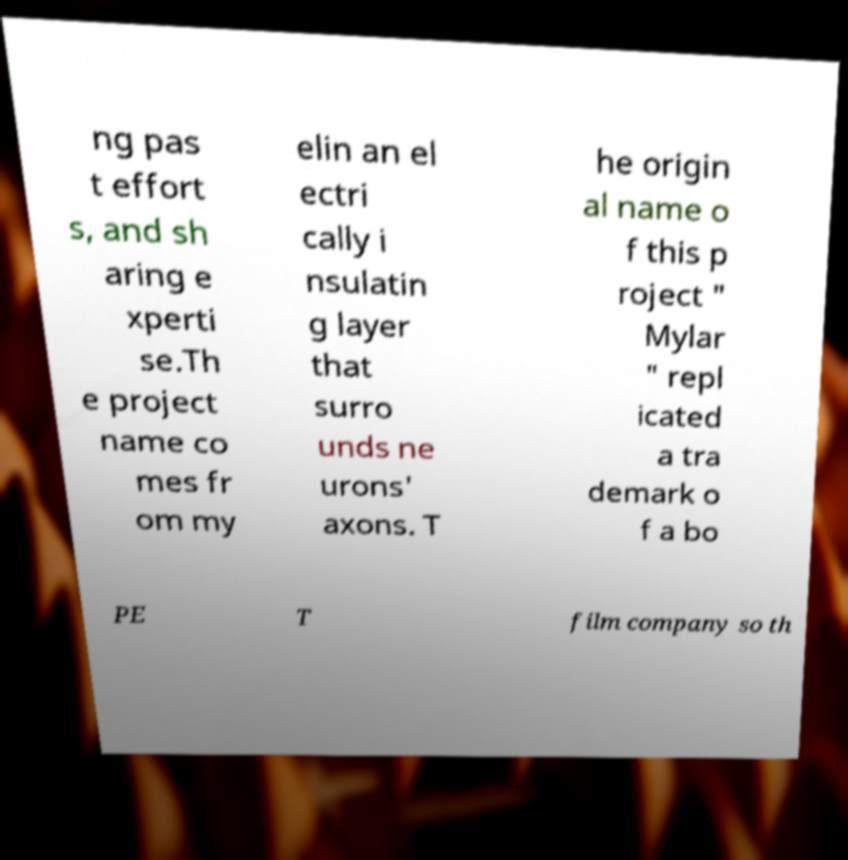Can you read and provide the text displayed in the image?This photo seems to have some interesting text. Can you extract and type it out for me? ng pas t effort s, and sh aring e xperti se.Th e project name co mes fr om my elin an el ectri cally i nsulatin g layer that surro unds ne urons' axons. T he origin al name o f this p roject " Mylar " repl icated a tra demark o f a bo PE T film company so th 